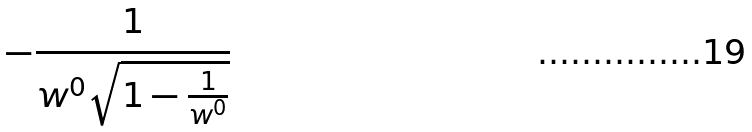<formula> <loc_0><loc_0><loc_500><loc_500>- \frac { 1 } { w ^ { 0 } \sqrt { 1 - \frac { 1 } { w ^ { 0 } } } }</formula> 